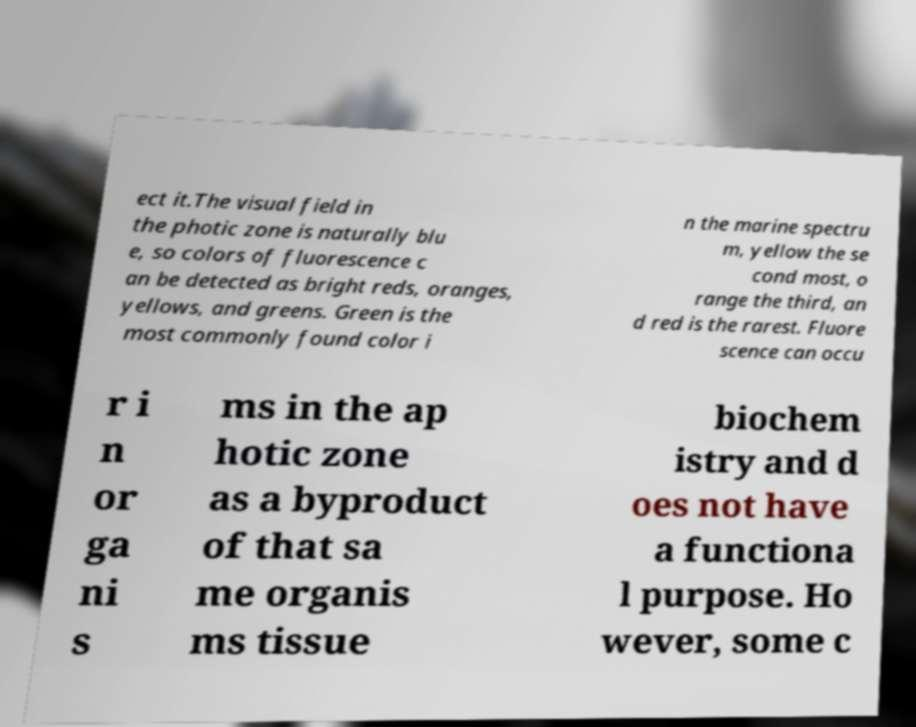Can you accurately transcribe the text from the provided image for me? ect it.The visual field in the photic zone is naturally blu e, so colors of fluorescence c an be detected as bright reds, oranges, yellows, and greens. Green is the most commonly found color i n the marine spectru m, yellow the se cond most, o range the third, an d red is the rarest. Fluore scence can occu r i n or ga ni s ms in the ap hotic zone as a byproduct of that sa me organis ms tissue biochem istry and d oes not have a functiona l purpose. Ho wever, some c 